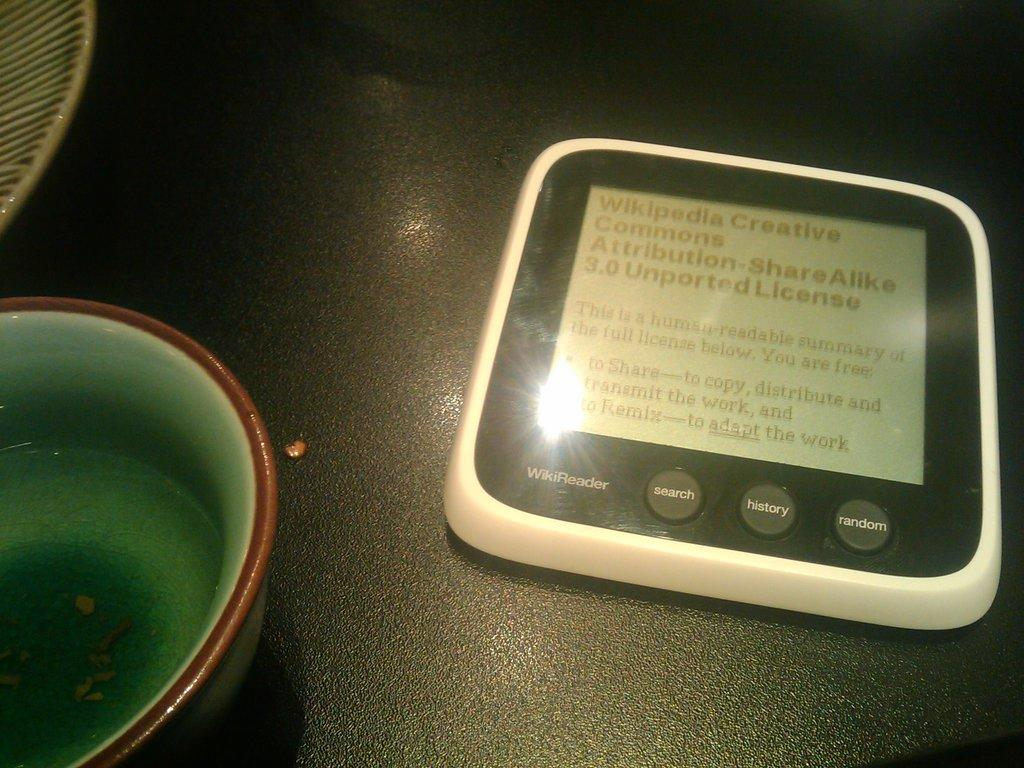What object can be seen in the image that might be used for a specific purpose? There is a device in the image, which might be used for a specific purpose. What is the flat, round object in the image? There is a plate in the image. What is the container with liquid in the image? There is a bowl with water in the image. On what surface are all the items placed? All the items are placed on a surface. Are there any active volcanoes visible in the image? No, there are no volcanoes present in the image. How many lizards can be seen interacting with the device in the image? There are no lizards present in the image. 